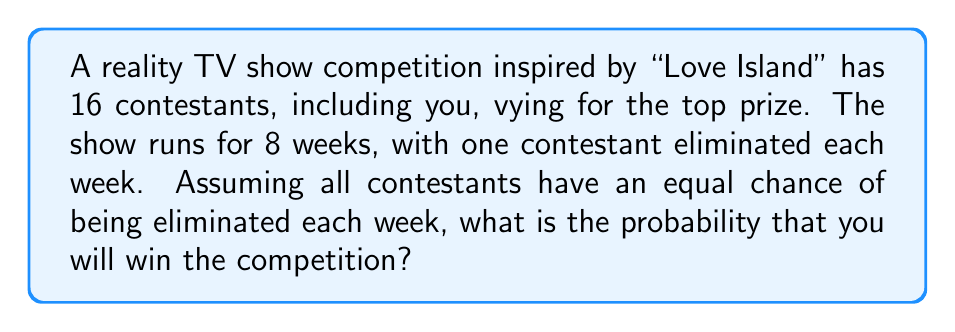Can you answer this question? Let's approach this step-by-step:

1) To win the competition, you need to survive all 7 eliminations (as the final week determines the winner).

2) For each week:
   - The probability of not being eliminated = $\frac{\text{number of survivors} - 1}{\text{number of survivors}}$

3) Let's calculate the probability for each week:
   Week 1: $P_1 = \frac{15}{16}$
   Week 2: $P_2 = \frac{14}{15}$
   Week 3: $P_3 = \frac{13}{14}$
   Week 4: $P_4 = \frac{12}{13}$
   Week 5: $P_5 = \frac{11}{12}$
   Week 6: $P_6 = \frac{10}{11}$
   Week 7: $P_7 = \frac{9}{10}$

4) The probability of surviving all 7 eliminations is the product of these probabilities:

   $$P(\text{winning}) = P_1 \times P_2 \times P_3 \times P_4 \times P_5 \times P_6 \times P_7$$

5) Substituting the values:

   $$P(\text{winning}) = \frac{15}{16} \times \frac{14}{15} \times \frac{13}{14} \times \frac{12}{13} \times \frac{11}{12} \times \frac{10}{11} \times \frac{9}{10}$$

6) This simplifies to:

   $$P(\text{winning}) = \frac{9}{16} = 0.5625$$

Therefore, the probability of winning the competition is $\frac{9}{16}$ or 0.5625 or 56.25%.
Answer: $\frac{9}{16}$ 